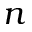Convert formula to latex. <formula><loc_0><loc_0><loc_500><loc_500>n</formula> 